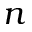Convert formula to latex. <formula><loc_0><loc_0><loc_500><loc_500>n</formula> 